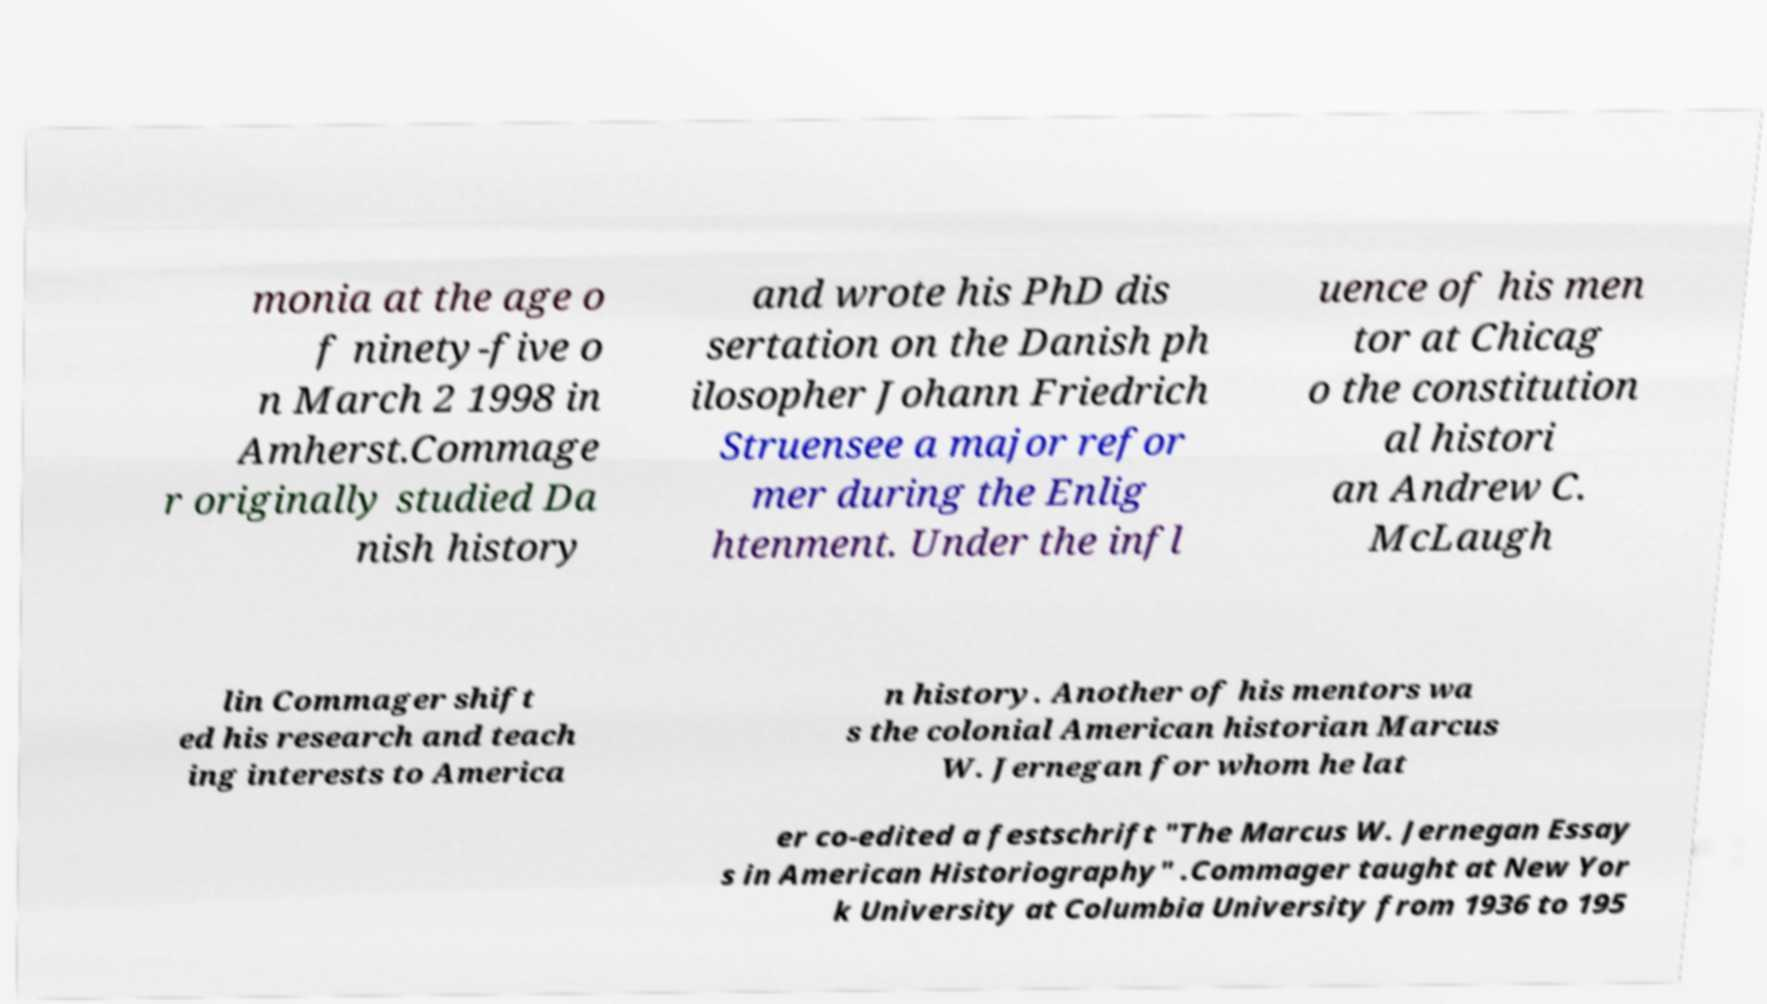Please identify and transcribe the text found in this image. monia at the age o f ninety-five o n March 2 1998 in Amherst.Commage r originally studied Da nish history and wrote his PhD dis sertation on the Danish ph ilosopher Johann Friedrich Struensee a major refor mer during the Enlig htenment. Under the infl uence of his men tor at Chicag o the constitution al histori an Andrew C. McLaugh lin Commager shift ed his research and teach ing interests to America n history. Another of his mentors wa s the colonial American historian Marcus W. Jernegan for whom he lat er co-edited a festschrift "The Marcus W. Jernegan Essay s in American Historiography" .Commager taught at New Yor k University at Columbia University from 1936 to 195 